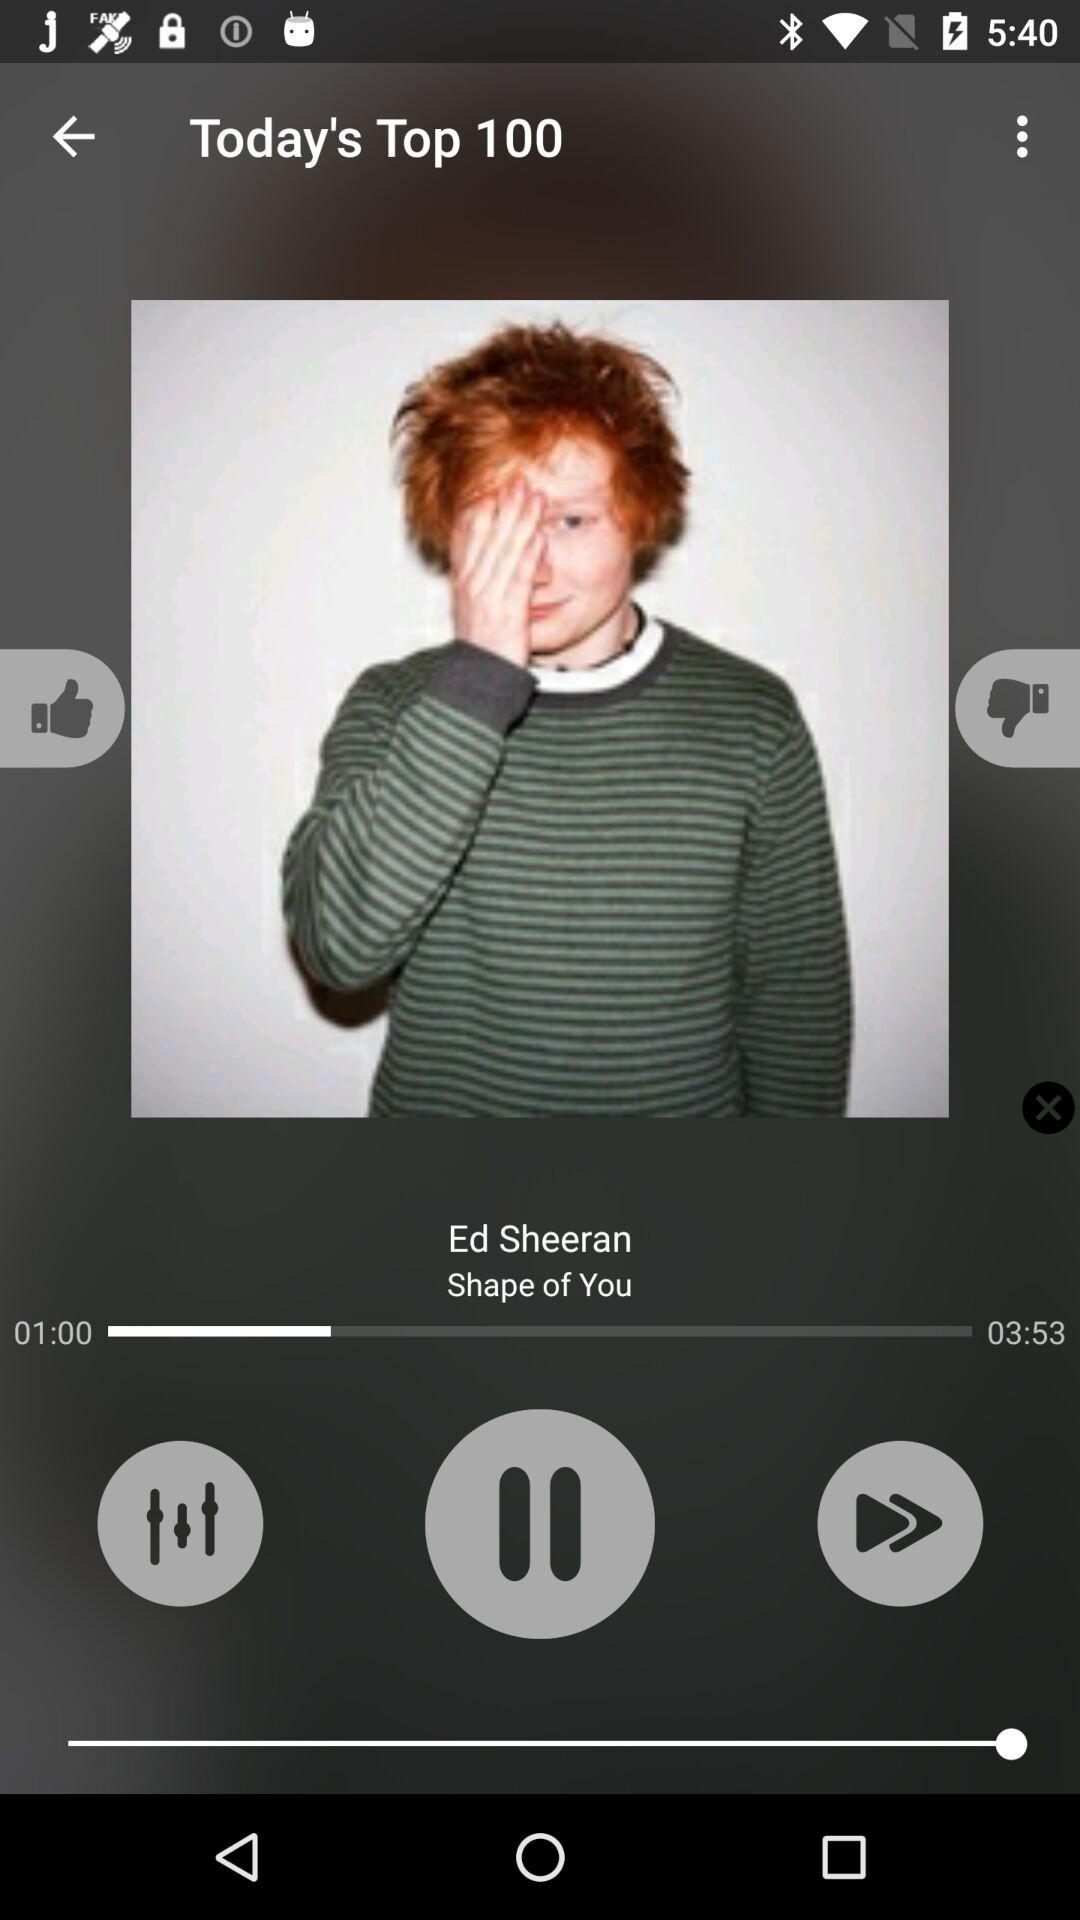For how long has the song been played? The song has been played for 1 minute. 